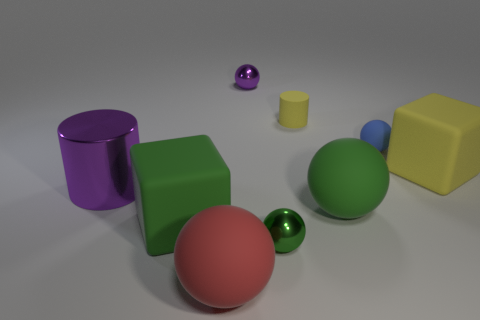The ball that is both behind the yellow matte cube and left of the tiny blue sphere is made of what material?
Keep it short and to the point. Metal. Does the rubber cylinder have the same size as the red object?
Provide a short and direct response. No. There is a shiny sphere behind the cylinder that is to the right of the large purple metal object; how big is it?
Make the answer very short. Small. How many small balls are both in front of the matte cylinder and left of the yellow matte cylinder?
Your answer should be compact. 1. Are there any rubber objects on the left side of the big green object that is to the right of the small sphere left of the small green ball?
Make the answer very short. Yes. What is the shape of the red rubber object that is the same size as the purple shiny cylinder?
Offer a terse response. Sphere. Are there any small objects that have the same color as the large metallic cylinder?
Your answer should be compact. Yes. Is the tiny yellow thing the same shape as the large shiny object?
Your answer should be very brief. Yes. What number of large objects are either green shiny objects or metallic cylinders?
Keep it short and to the point. 1. What color is the small thing that is the same material as the purple ball?
Provide a short and direct response. Green. 